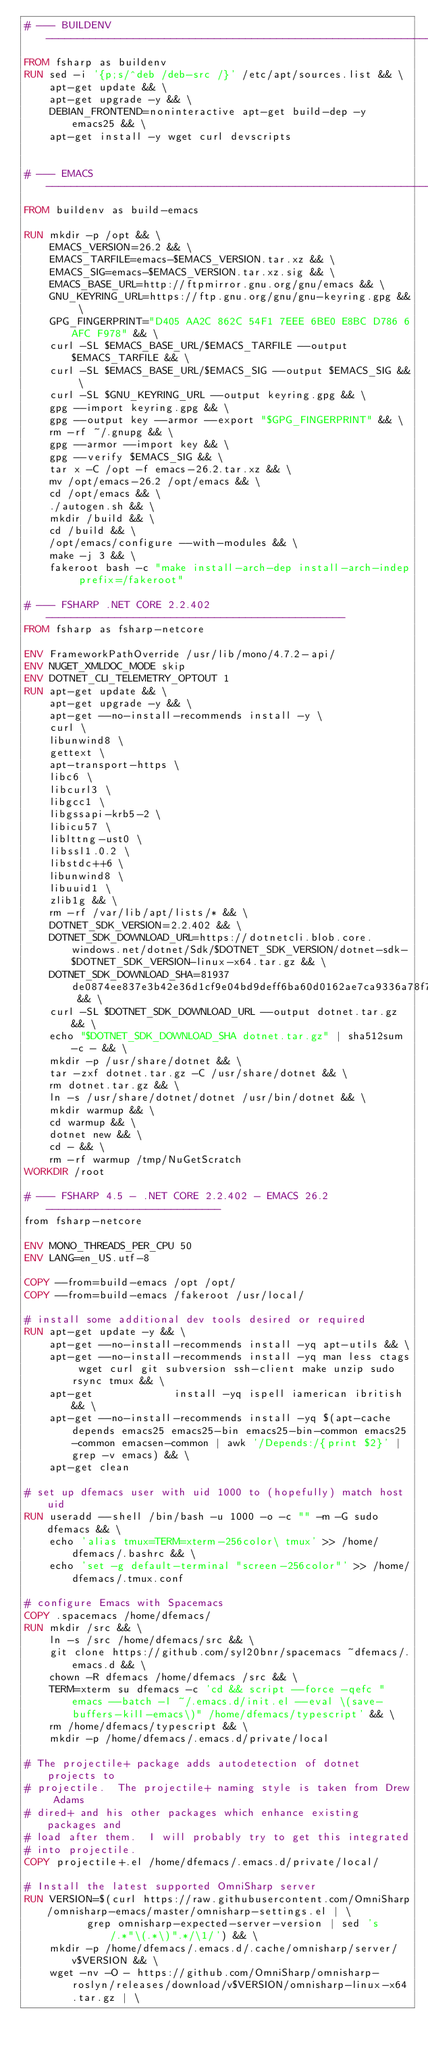Convert code to text. <code><loc_0><loc_0><loc_500><loc_500><_Dockerfile_># --- BUILDENV ----------------------------------------------------------------
FROM fsharp as buildenv
RUN sed -i '{p;s/^deb /deb-src /}' /etc/apt/sources.list && \
    apt-get update && \
    apt-get upgrade -y && \
    DEBIAN_FRONTEND=noninteractive apt-get build-dep -y emacs25 && \
    apt-get install -y wget curl devscripts


# --- EMACS -------------------------------------------------------------------
FROM buildenv as build-emacs

RUN mkdir -p /opt && \
    EMACS_VERSION=26.2 && \
    EMACS_TARFILE=emacs-$EMACS_VERSION.tar.xz && \
    EMACS_SIG=emacs-$EMACS_VERSION.tar.xz.sig && \
    EMACS_BASE_URL=http://ftpmirror.gnu.org/gnu/emacs && \
    GNU_KEYRING_URL=https://ftp.gnu.org/gnu/gnu-keyring.gpg && \
    GPG_FINGERPRINT="D405 AA2C 862C 54F1 7EEE 6BE0 E8BC D786 6AFC F978" && \
    curl -SL $EMACS_BASE_URL/$EMACS_TARFILE --output $EMACS_TARFILE && \
    curl -SL $EMACS_BASE_URL/$EMACS_SIG --output $EMACS_SIG && \
    curl -SL $GNU_KEYRING_URL --output keyring.gpg && \
    gpg --import keyring.gpg && \
    gpg --output key --armor --export "$GPG_FINGERPRINT" && \
    rm -rf ~/.gnupg && \
    gpg --armor --import key && \
    gpg --verify $EMACS_SIG && \
    tar x -C /opt -f emacs-26.2.tar.xz && \
    mv /opt/emacs-26.2 /opt/emacs && \
    cd /opt/emacs && \
    ./autogen.sh && \
    mkdir /build && \
    cd /build && \
    /opt/emacs/configure --with-modules && \
    make -j 3 && \
    fakeroot bash -c "make install-arch-dep install-arch-indep prefix=/fakeroot"

# --- FSHARP .NET CORE 2.2.402 ------------------------------------------------
FROM fsharp as fsharp-netcore

ENV FrameworkPathOverride /usr/lib/mono/4.7.2-api/
ENV NUGET_XMLDOC_MODE skip
ENV DOTNET_CLI_TELEMETRY_OPTOUT 1
RUN apt-get update && \
    apt-get upgrade -y && \
    apt-get --no-install-recommends install -y \
    curl \
    libunwind8 \
    gettext \
    apt-transport-https \
    libc6 \
    libcurl3 \
    libgcc1 \
    libgssapi-krb5-2 \
    libicu57 \
    liblttng-ust0 \
    libssl1.0.2 \
    libstdc++6 \
    libunwind8 \
    libuuid1 \
    zlib1g && \
    rm -rf /var/lib/apt/lists/* && \
    DOTNET_SDK_VERSION=2.2.402 && \
    DOTNET_SDK_DOWNLOAD_URL=https://dotnetcli.blob.core.windows.net/dotnet/Sdk/$DOTNET_SDK_VERSION/dotnet-sdk-$DOTNET_SDK_VERSION-linux-x64.tar.gz && \
    DOTNET_SDK_DOWNLOAD_SHA=81937de0874ee837e3b42e36d1cf9e04bd9deff6ba60d0162ae7ca9336a78f733e624136d27f559728df3f681a72a669869bf91d02db47c5331398c0cfda9b44 && \
    curl -SL $DOTNET_SDK_DOWNLOAD_URL --output dotnet.tar.gz && \
    echo "$DOTNET_SDK_DOWNLOAD_SHA dotnet.tar.gz" | sha512sum -c - && \
    mkdir -p /usr/share/dotnet && \
    tar -zxf dotnet.tar.gz -C /usr/share/dotnet && \
    rm dotnet.tar.gz && \
    ln -s /usr/share/dotnet/dotnet /usr/bin/dotnet && \
    mkdir warmup && \
    cd warmup && \
    dotnet new && \
    cd - && \
    rm -rf warmup /tmp/NuGetScratch
WORKDIR /root

# --- FSHARP 4.5 - .NET CORE 2.2.402 - EMACS 26.2  ----------------------------
from fsharp-netcore

ENV MONO_THREADS_PER_CPU 50
ENV LANG=en_US.utf-8

COPY --from=build-emacs /opt /opt/
COPY --from=build-emacs /fakeroot /usr/local/

# install some additional dev tools desired or required
RUN apt-get update -y && \
    apt-get --no-install-recommends install -yq apt-utils && \
    apt-get --no-install-recommends install -yq man less ctags wget curl git subversion ssh-client make unzip sudo rsync tmux && \
    apt-get			    install -yq ispell iamerican ibritish && \
    apt-get --no-install-recommends install -yq $(apt-cache depends emacs25 emacs25-bin emacs25-bin-common emacs25-common emacsen-common | awk '/Depends:/{print $2}' | grep -v emacs) && \
    apt-get clean

# set up dfemacs user with uid 1000 to (hopefully) match host uid
RUN useradd --shell /bin/bash -u 1000 -o -c "" -m -G sudo dfemacs && \
    echo 'alias tmux=TERM=xterm-256color\ tmux' >> /home/dfemacs/.bashrc && \
    echo 'set -g default-terminal "screen-256color"' >> /home/dfemacs/.tmux.conf

# configure Emacs with Spacemacs
COPY .spacemacs /home/dfemacs/
RUN mkdir /src && \
    ln -s /src /home/dfemacs/src && \
    git clone https://github.com/syl20bnr/spacemacs ~dfemacs/.emacs.d && \
    chown -R dfemacs /home/dfemacs /src && \
    TERM=xterm su dfemacs -c 'cd && script --force -qefc "emacs --batch -l ~/.emacs.d/init.el --eval \(save-buffers-kill-emacs\)" /home/dfemacs/typescript' && \
    rm /home/dfemacs/typescript && \
	mkdir -p /home/dfemacs/.emacs.d/private/local

# The projectile+ package adds autodetection of dotnet projects to
# projectile.  The projectile+ naming style is taken from Drew Adams
# dired+ and his other packages which enhance existing packages and
# load after them.  I will probably try to get this integrated
# into projectile.
COPY projectile+.el /home/dfemacs/.emacs.d/private/local/

# Install the latest supported OmniSharp server
RUN VERSION=$(curl https://raw.githubusercontent.com/OmniSharp/omnisharp-emacs/master/omnisharp-settings.el | \
	      grep omnisharp-expected-server-version | sed 's/.*"\(.*\)".*/\1/') && \
    mkdir -p /home/dfemacs/.emacs.d/.cache/omnisharp/server/v$VERSION && \
    wget -nv -O - https://github.com/OmniSharp/omnisharp-roslyn/releases/download/v$VERSION/omnisharp-linux-x64.tar.gz | \</code> 